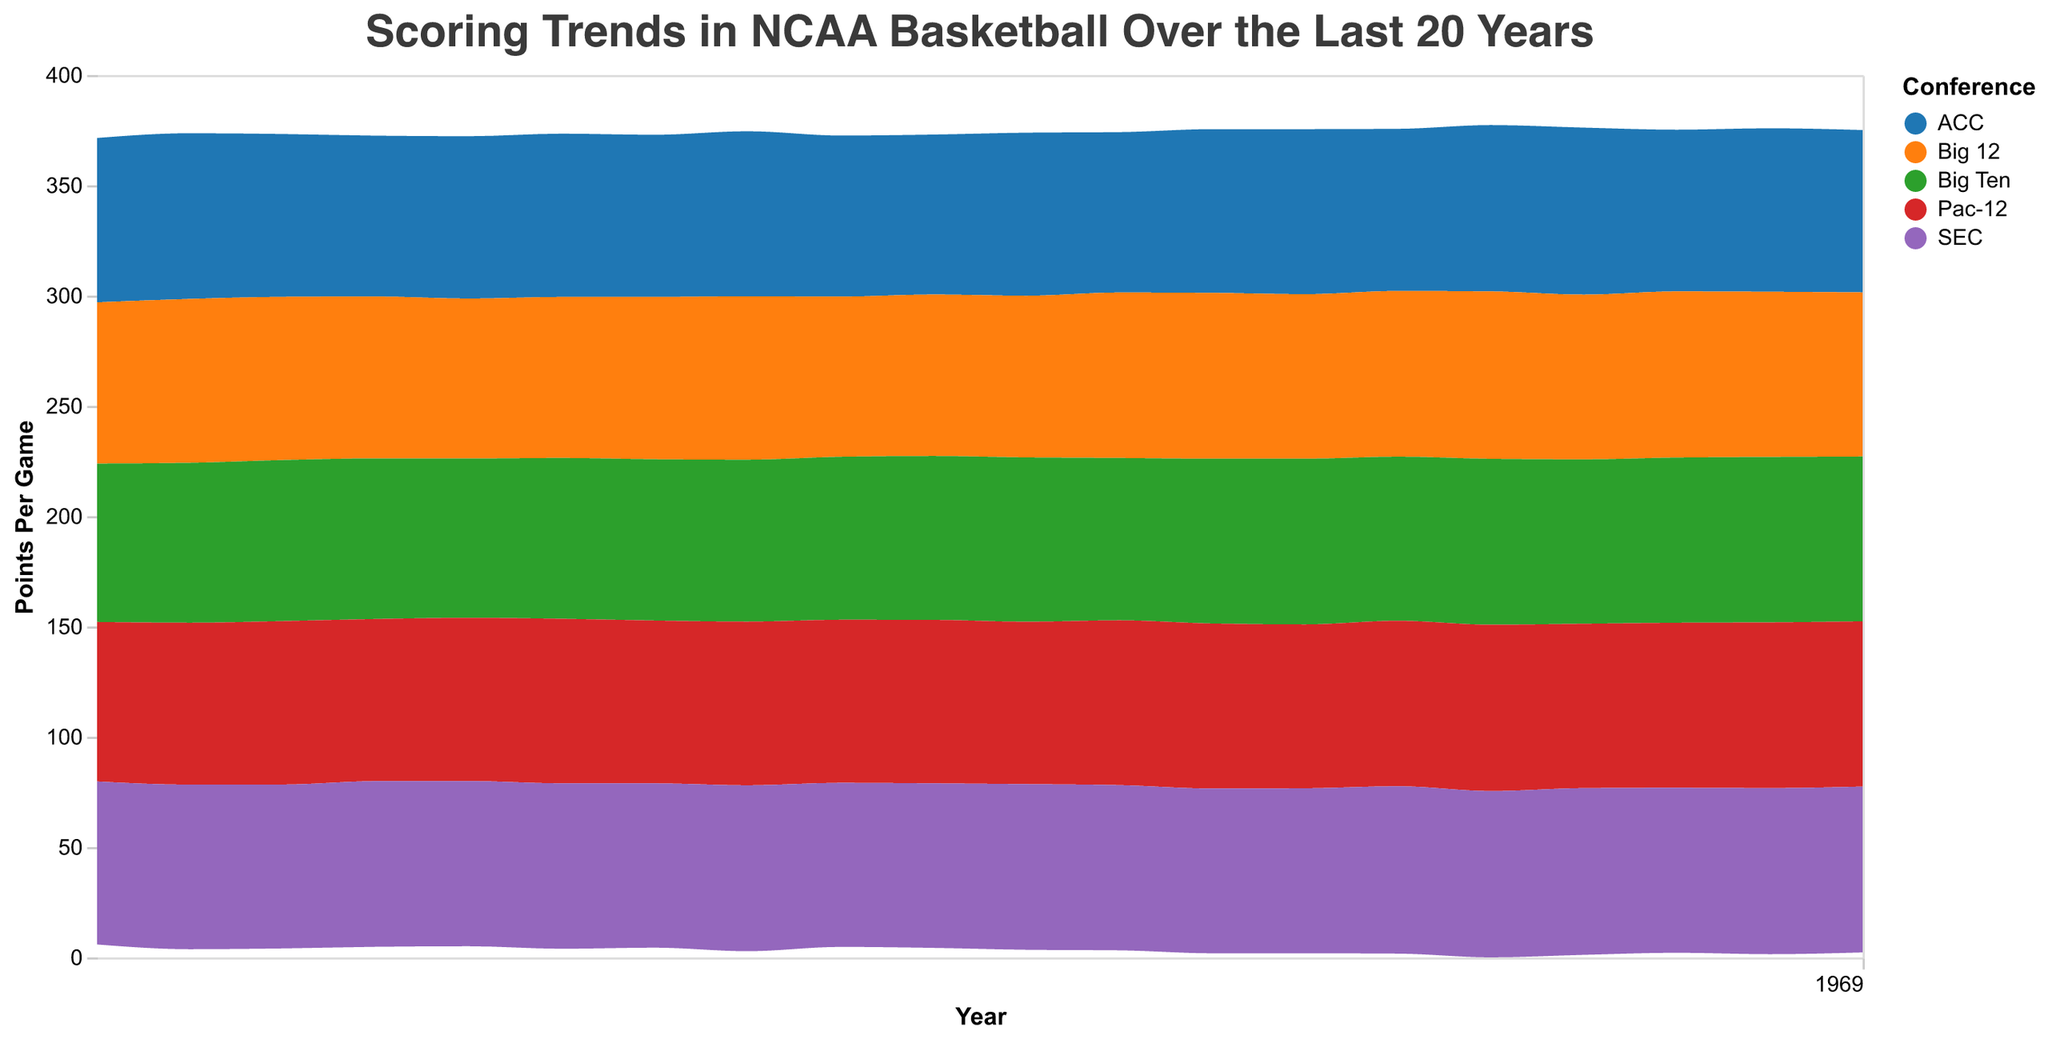Which conference had the highest scoring average in 2019? Looking at the stream graph, each conference is represented by a different color. By finding the year 2019 on the x-axis and identifying which conference's area is highest in that year, we can determine the highest scoring average.
Answer: ACC Has the scoring trend in the Pac-12 increased, decreased, or remained stable from 2003 to 2022? Locate the beginning year (2003) and the end year (2022) for the Pac-12 conference. Compare the positions of the areas for the conference between these two years to evaluate the trend.
Answer: Increased Which conference showed the most variation in points per game over the 20-year period? Identify the area that shows the most vertical fluctuation across the entire x-axis from 2003 to 2022. This can be deduced by observing the visual width of each stream.
Answer: Big Ten When comparing scoring trends in 2017, which conference had a lower scoring average, Pac-12 or Big 12? Observe the relative heights of the Pac-12 and Big 12 streams in the year 2017. The conference with a lower height has a lower scoring average.
Answer: Pac-12 In which year did the SEC conference reach its peak points per game? Follow the SEC's stream and identify the year where its area reaches the highest point on the y-axis.
Answer: 2017 Has the ACC conference ever been the highest-scoring conference in any given year? Scan through the years and check if the ACC's area reaches the highest point on the y-axis more than any other conference's area in any specific year.
Answer: Yes What is the overall scoring trend of the Big 12 conference from 2003 to 2010? Look at the Big 12's stream from 2003 to 2010 and notice the overall direction from the start to end. Sum of individual year points can be visually estimated by connecting midpoints of each year.
Answer: Increasing Which year and conference combination had the lowest points per game in the entire dataset? Identify the thinnest portion of any stream and note the corresponding conference and year. This represents the lowest points per game.
Answer: Big 12, 2007 Among the conferences, which one shows a consistent scoring trend with minimal fluctuation over 20 years? Identify the stream with the most uniform width and shape over the 20 years, indicating minimal fluctuations.
Answer: Pac-12 